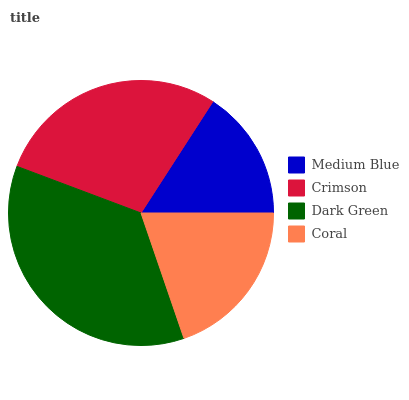Is Medium Blue the minimum?
Answer yes or no. Yes. Is Dark Green the maximum?
Answer yes or no. Yes. Is Crimson the minimum?
Answer yes or no. No. Is Crimson the maximum?
Answer yes or no. No. Is Crimson greater than Medium Blue?
Answer yes or no. Yes. Is Medium Blue less than Crimson?
Answer yes or no. Yes. Is Medium Blue greater than Crimson?
Answer yes or no. No. Is Crimson less than Medium Blue?
Answer yes or no. No. Is Crimson the high median?
Answer yes or no. Yes. Is Coral the low median?
Answer yes or no. Yes. Is Coral the high median?
Answer yes or no. No. Is Dark Green the low median?
Answer yes or no. No. 